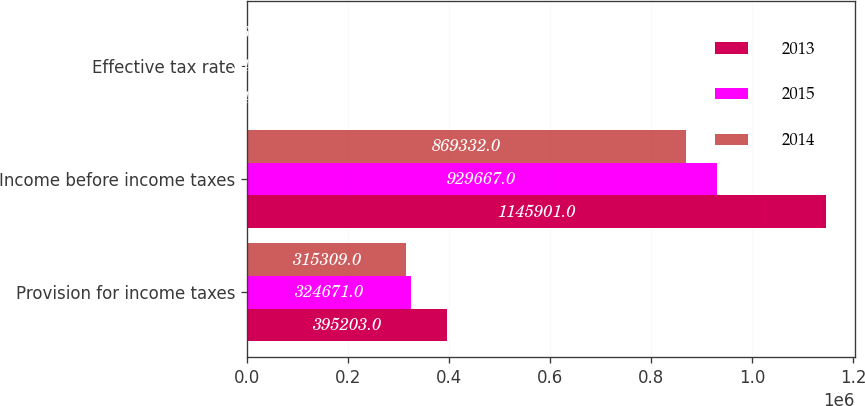Convert chart to OTSL. <chart><loc_0><loc_0><loc_500><loc_500><stacked_bar_chart><ecel><fcel>Provision for income taxes<fcel>Income before income taxes<fcel>Effective tax rate<nl><fcel>2013<fcel>395203<fcel>1.1459e+06<fcel>34.5<nl><fcel>2015<fcel>324671<fcel>929667<fcel>34.9<nl><fcel>2014<fcel>315309<fcel>869332<fcel>36.3<nl></chart> 